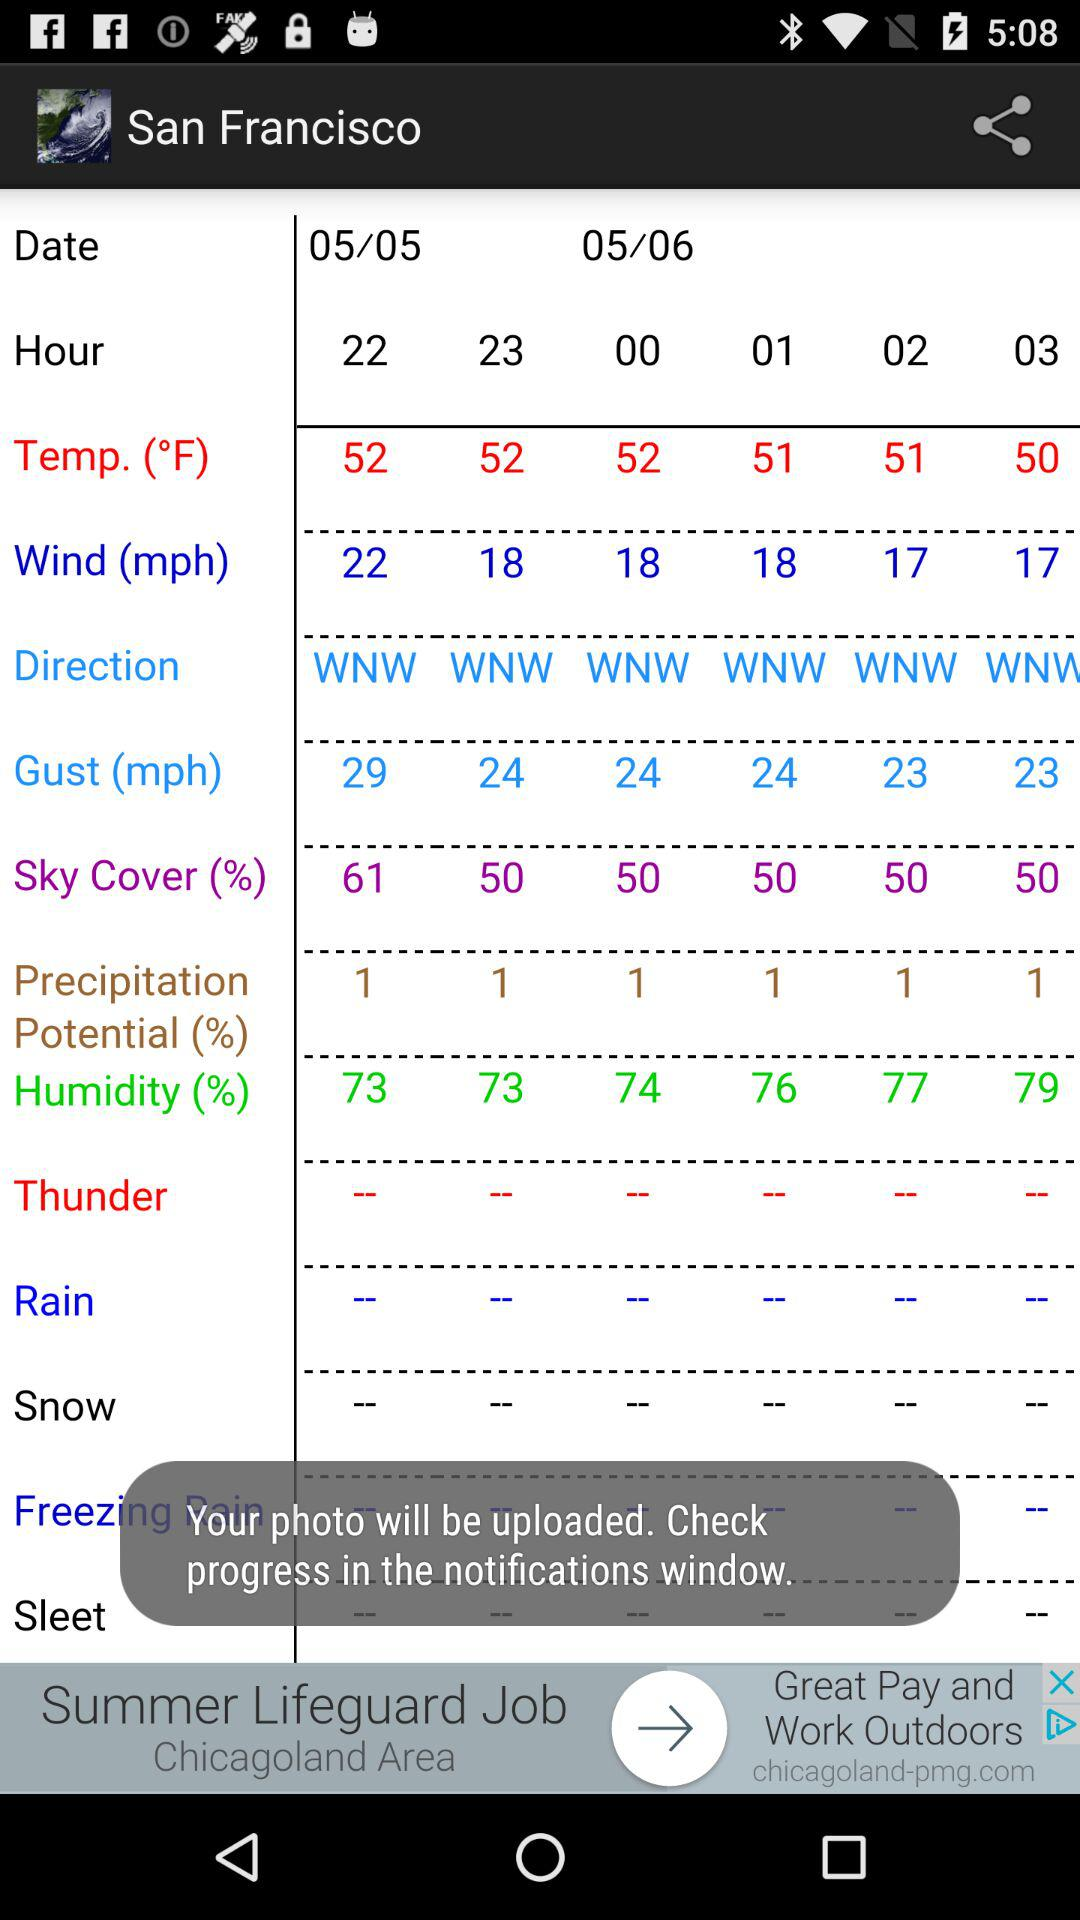What is the percentage of sky cover?
Answer the question using a single word or phrase. 61% 